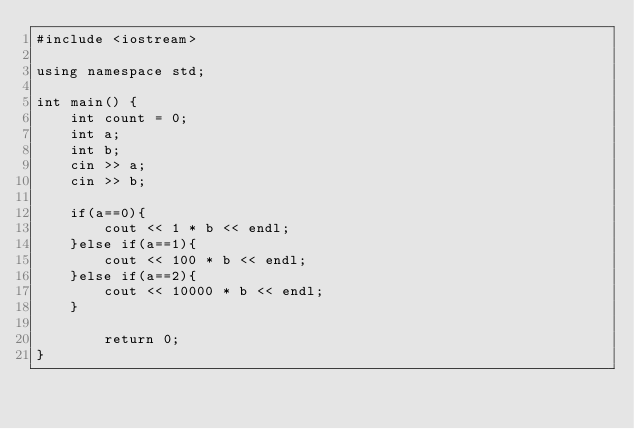<code> <loc_0><loc_0><loc_500><loc_500><_C++_>#include <iostream>
 
using namespace std;
 
int main() {
    int count = 0;
    int a;
    int b;
    cin >> a;
    cin >> b;
    
    if(a==0){
        cout << 1 * b << endl;
    }else if(a==1){
        cout << 100 * b << endl;
    }else if(a==2){
        cout << 10000 * b << endl;
    }
        
        return 0;
}</code> 